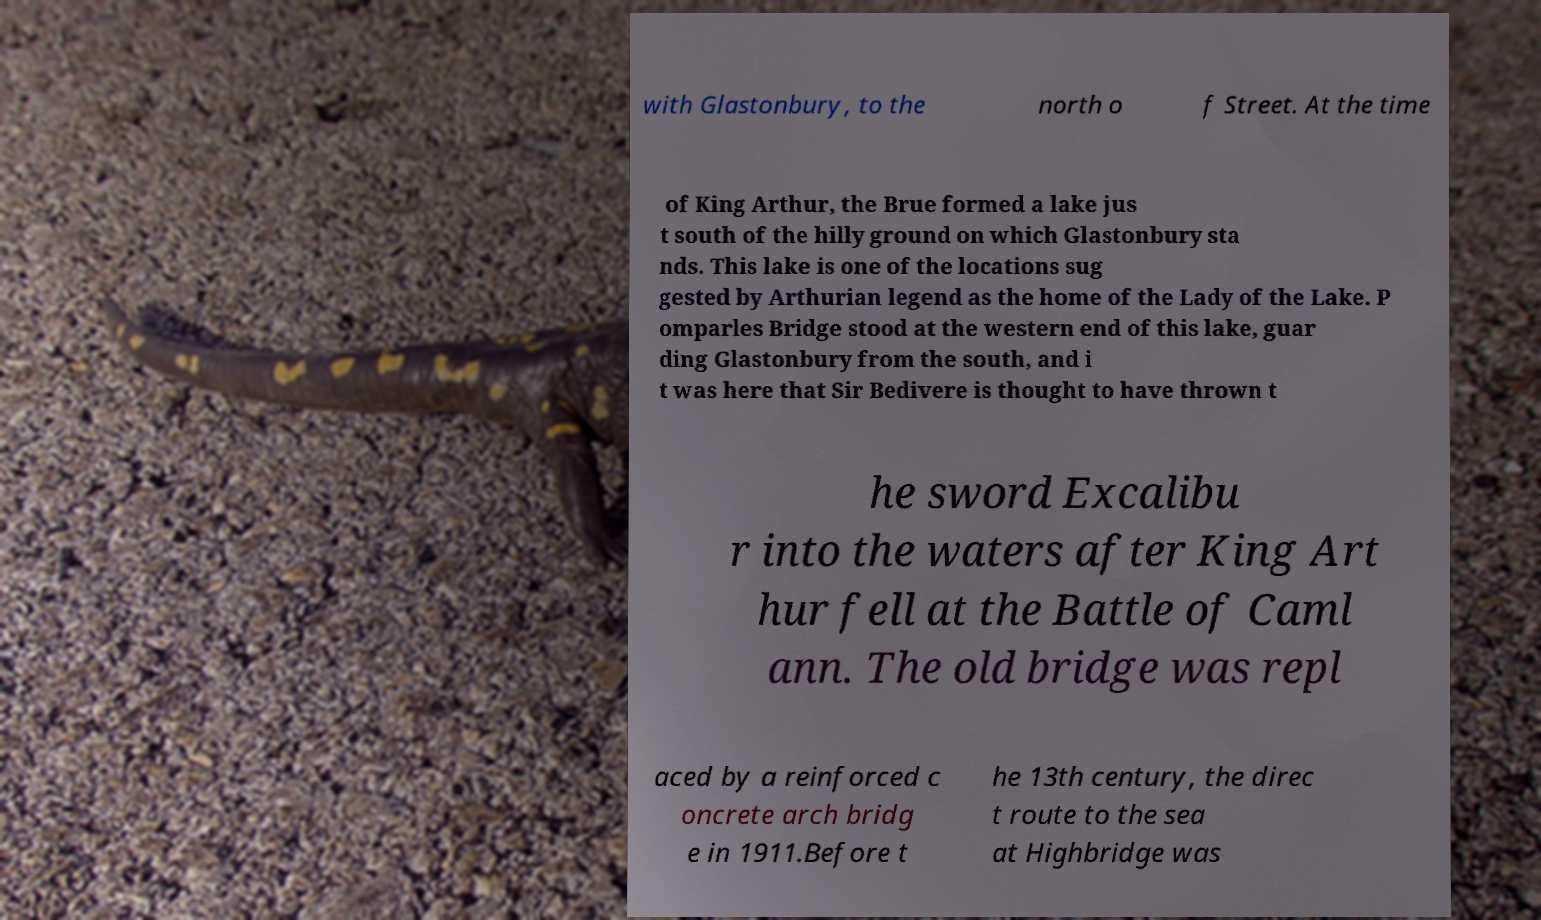Can you accurately transcribe the text from the provided image for me? with Glastonbury, to the north o f Street. At the time of King Arthur, the Brue formed a lake jus t south of the hilly ground on which Glastonbury sta nds. This lake is one of the locations sug gested by Arthurian legend as the home of the Lady of the Lake. P omparles Bridge stood at the western end of this lake, guar ding Glastonbury from the south, and i t was here that Sir Bedivere is thought to have thrown t he sword Excalibu r into the waters after King Art hur fell at the Battle of Caml ann. The old bridge was repl aced by a reinforced c oncrete arch bridg e in 1911.Before t he 13th century, the direc t route to the sea at Highbridge was 